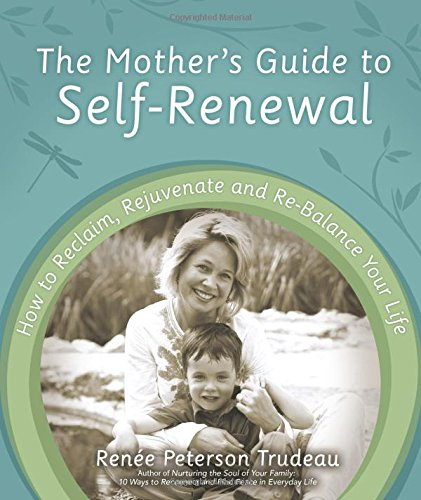What is the title of this book? The title of the book is 'The Mother's Guide to Self-Renewal: How to Reclaim, Rejuvenate and Re-Balance Your Life'. It offers insights into how mothers can focus on personal growth and well-being. 